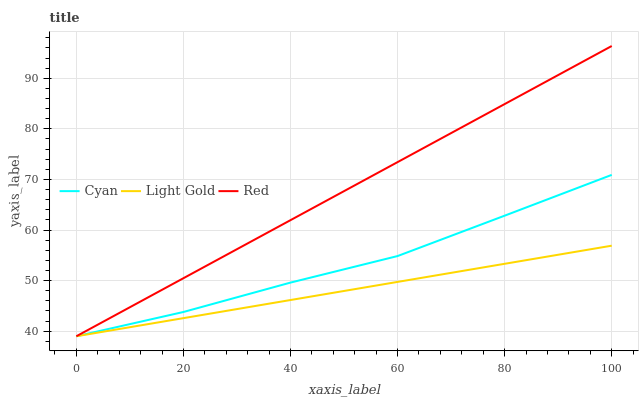Does Light Gold have the minimum area under the curve?
Answer yes or no. Yes. Does Red have the maximum area under the curve?
Answer yes or no. Yes. Does Red have the minimum area under the curve?
Answer yes or no. No. Does Light Gold have the maximum area under the curve?
Answer yes or no. No. Is Light Gold the smoothest?
Answer yes or no. Yes. Is Cyan the roughest?
Answer yes or no. Yes. Is Red the smoothest?
Answer yes or no. No. Is Red the roughest?
Answer yes or no. No. Does Light Gold have the highest value?
Answer yes or no. No. 